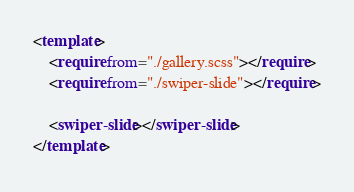Convert code to text. <code><loc_0><loc_0><loc_500><loc_500><_HTML_><template>
    <require from="./gallery.scss"></require>
    <require from="./swiper-slide"></require>

    <swiper-slide></swiper-slide>
</template>
</code> 